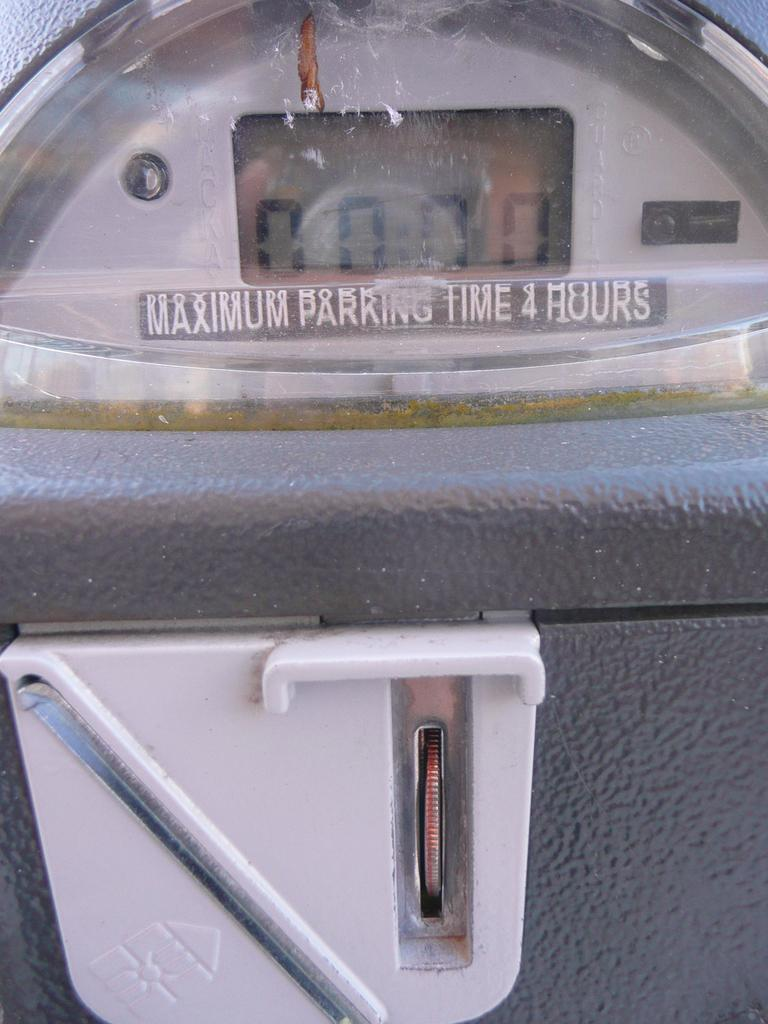<image>
Provide a brief description of the given image. A parking meter that has Maximum parking time 4 hours under the display. 